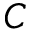<formula> <loc_0><loc_0><loc_500><loc_500>C</formula> 